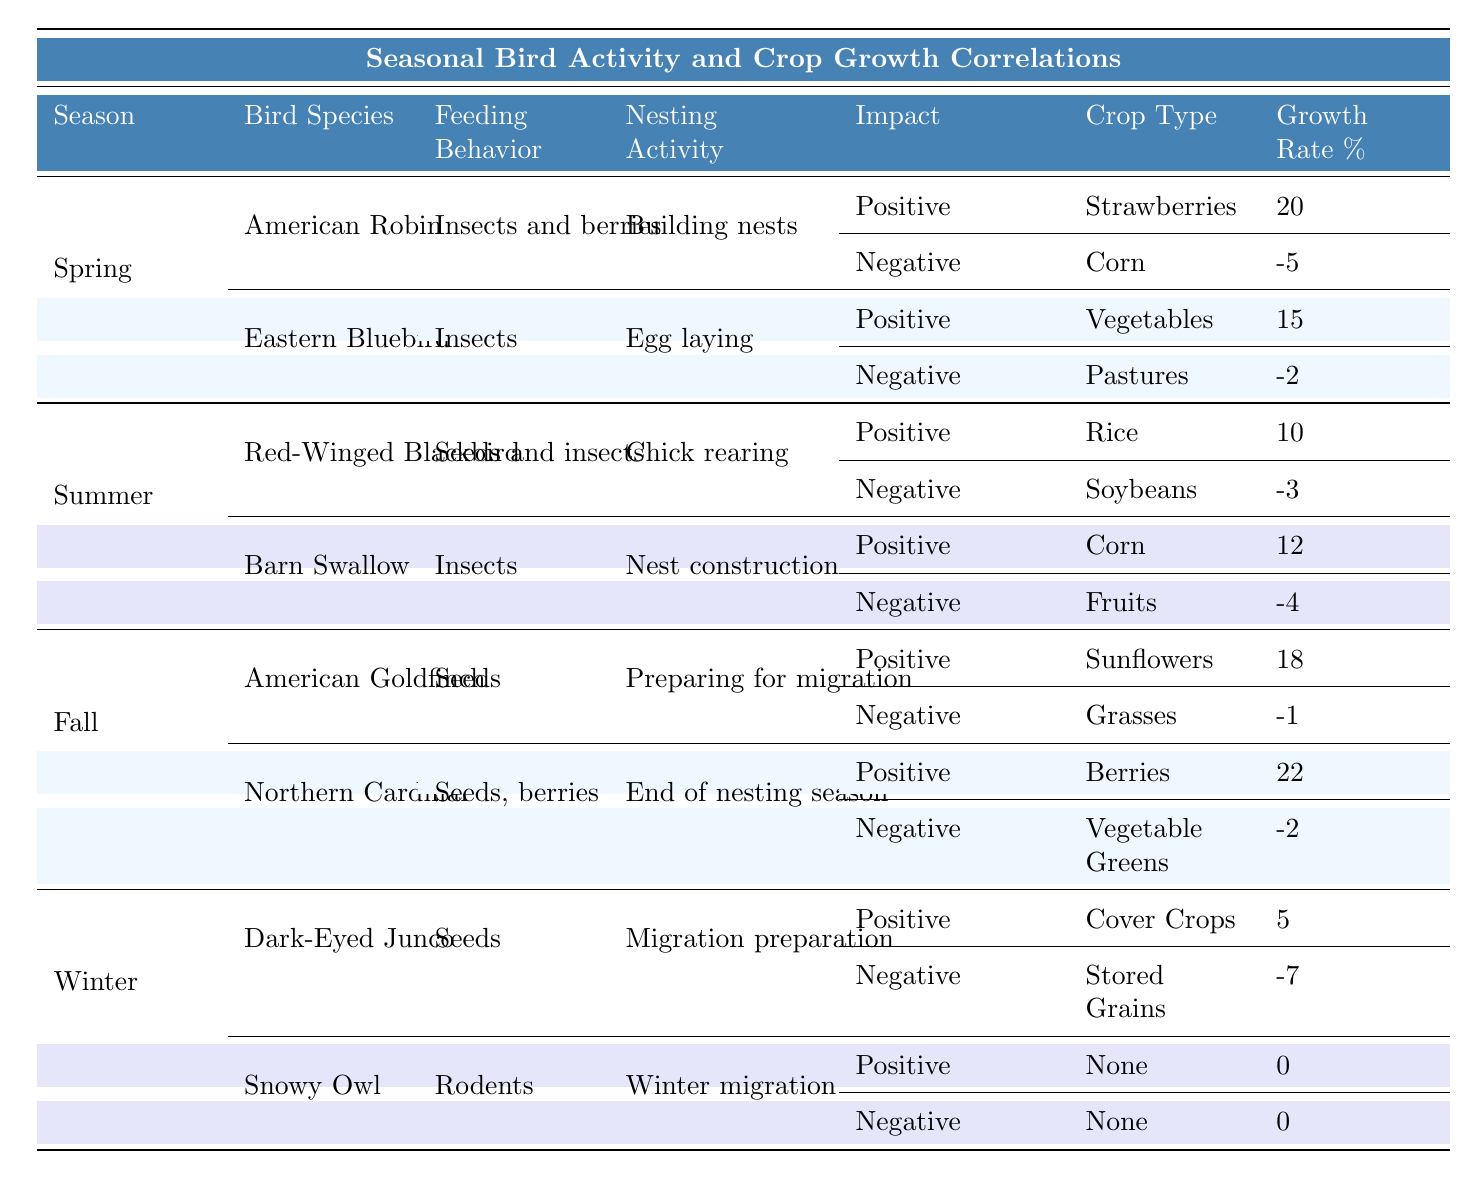What is the feeding behavior of the American Robin in spring? The table states that the American Robin feeds on insects and berries in spring.
Answer: Insects and berries Which crop type has the highest positive impact from the Northern Cardinal? According to the table, the highest positive impact from the Northern Cardinal in the fall is on berries, with a growth rate of 22%.
Answer: Berries What is the negative impact on corn due to the Barn Swallow's activity in summer? The table shows that the negative impact on corn from the Barn Swallow is a growth rate of -4%.
Answer: -4% How does the pest reduction percentage of the Eastern Bluebird compare to that of the American Goldfinch? The Eastern Bluebird reduces pests by 25%, while the American Goldfinch reduces pests by 20%. The Eastern Bluebird has a higher pest reduction percentage than the American Goldfinch.
Answer: Higher What is the total growth rate percentage for crops with positive impacts from spring bird activities? The positive impacts in spring are 20% for strawberries and 15% for vegetables. The total is 20 + 15 = 35%.
Answer: 35% Is the feeding behavior of the Snowy Owl related to the growth of any crops? The table indicates that the Snowy Owl has a positive impact on crops categorized as "None," meaning it does not contribute to crop growth. Therefore, the statement is true.
Answer: Yes, it's unrelated Which bird species had a negative impact on the highest number of crop types? Evaluating the table, both the Red-Winged Blackbird and Barn Swallow had negative impacts on two crop types. Thus, no bird outnumbers these species.
Answer: Tie between two species What crop type benefits from the feeding behavior of the Dark-Eyed Junco in winter? The Dark-Eyed Junco positively impacts cover crops, with a growth rate of 5% as indicated in the table.
Answer: Cover Crops If the pest reduction percentage were to double for the American Goldfinch, what would it be? The table states that the pest reduction percentage for the American Goldfinch is 20%. If doubled, it would be 20% x 2 = 40%.
Answer: 40% What is the difference in growth rate percentages between the American Robin's positive and negative impacts on crops? The positive impact for the American Robin is 20% for strawberries, while the negative impact on corn is -5%. Their difference is 20 - (-5) = 25%.
Answer: 25% 